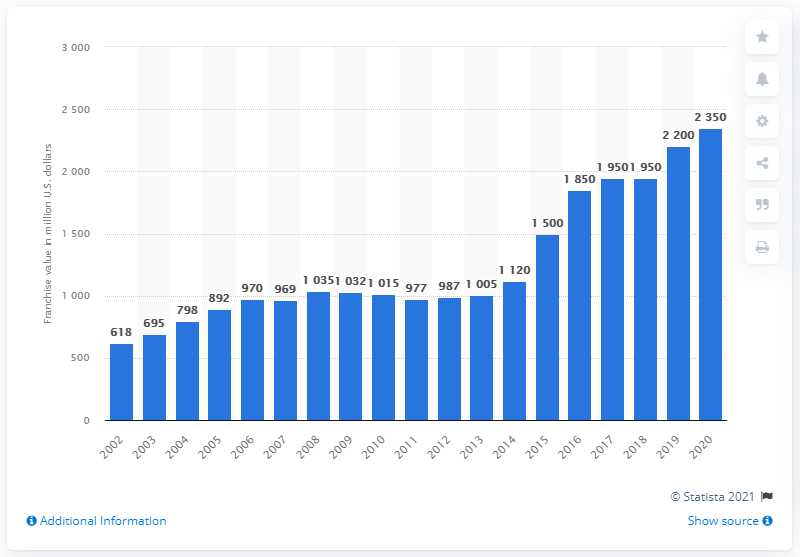Point out several critical features in this image. The franchise value of the Cleveland Browns in 2020 was approximately $2350 in dollars. 